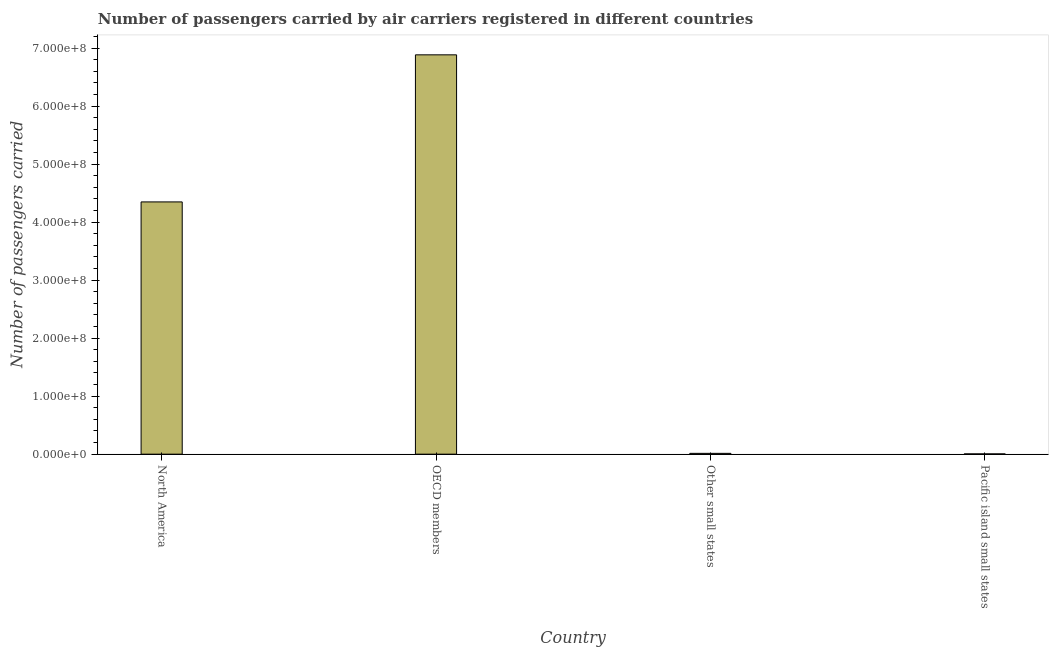What is the title of the graph?
Offer a terse response. Number of passengers carried by air carriers registered in different countries. What is the label or title of the X-axis?
Ensure brevity in your answer.  Country. What is the label or title of the Y-axis?
Ensure brevity in your answer.  Number of passengers carried. What is the number of passengers carried in Other small states?
Your answer should be compact. 1.41e+06. Across all countries, what is the maximum number of passengers carried?
Your response must be concise. 6.89e+08. Across all countries, what is the minimum number of passengers carried?
Your answer should be compact. 4.56e+05. In which country was the number of passengers carried maximum?
Give a very brief answer. OECD members. In which country was the number of passengers carried minimum?
Provide a succinct answer. Pacific island small states. What is the sum of the number of passengers carried?
Provide a short and direct response. 1.13e+09. What is the difference between the number of passengers carried in North America and Other small states?
Provide a short and direct response. 4.34e+08. What is the average number of passengers carried per country?
Keep it short and to the point. 2.81e+08. What is the median number of passengers carried?
Give a very brief answer. 2.18e+08. In how many countries, is the number of passengers carried greater than 320000000 ?
Ensure brevity in your answer.  2. What is the ratio of the number of passengers carried in OECD members to that in Pacific island small states?
Ensure brevity in your answer.  1510.56. Is the difference between the number of passengers carried in OECD members and Pacific island small states greater than the difference between any two countries?
Keep it short and to the point. Yes. What is the difference between the highest and the second highest number of passengers carried?
Your answer should be compact. 2.54e+08. Is the sum of the number of passengers carried in North America and OECD members greater than the maximum number of passengers carried across all countries?
Your answer should be compact. Yes. What is the difference between the highest and the lowest number of passengers carried?
Make the answer very short. 6.88e+08. In how many countries, is the number of passengers carried greater than the average number of passengers carried taken over all countries?
Ensure brevity in your answer.  2. What is the difference between two consecutive major ticks on the Y-axis?
Your answer should be very brief. 1.00e+08. What is the Number of passengers carried in North America?
Your response must be concise. 4.35e+08. What is the Number of passengers carried of OECD members?
Your answer should be compact. 6.89e+08. What is the Number of passengers carried in Other small states?
Give a very brief answer. 1.41e+06. What is the Number of passengers carried of Pacific island small states?
Offer a terse response. 4.56e+05. What is the difference between the Number of passengers carried in North America and OECD members?
Your response must be concise. -2.54e+08. What is the difference between the Number of passengers carried in North America and Other small states?
Your answer should be compact. 4.34e+08. What is the difference between the Number of passengers carried in North America and Pacific island small states?
Your response must be concise. 4.34e+08. What is the difference between the Number of passengers carried in OECD members and Other small states?
Your response must be concise. 6.87e+08. What is the difference between the Number of passengers carried in OECD members and Pacific island small states?
Your answer should be compact. 6.88e+08. What is the difference between the Number of passengers carried in Other small states and Pacific island small states?
Offer a very short reply. 9.53e+05. What is the ratio of the Number of passengers carried in North America to that in OECD members?
Your answer should be compact. 0.63. What is the ratio of the Number of passengers carried in North America to that in Other small states?
Offer a very short reply. 308.77. What is the ratio of the Number of passengers carried in North America to that in Pacific island small states?
Ensure brevity in your answer.  954.22. What is the ratio of the Number of passengers carried in OECD members to that in Other small states?
Give a very brief answer. 488.79. What is the ratio of the Number of passengers carried in OECD members to that in Pacific island small states?
Offer a terse response. 1510.56. What is the ratio of the Number of passengers carried in Other small states to that in Pacific island small states?
Your answer should be compact. 3.09. 